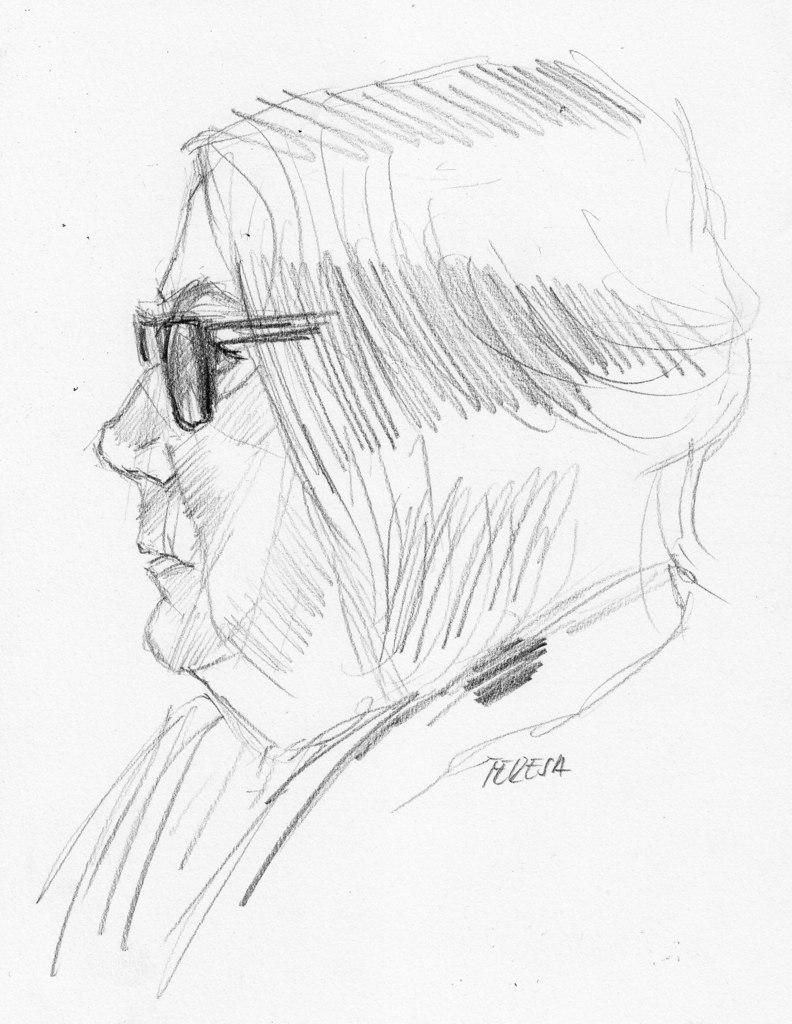What is the main subject of the image? There is a drawing in the image. What type of lace is used to create the trousers in the drawing? There is no drawing of trousers or any mention of lace in the image. 